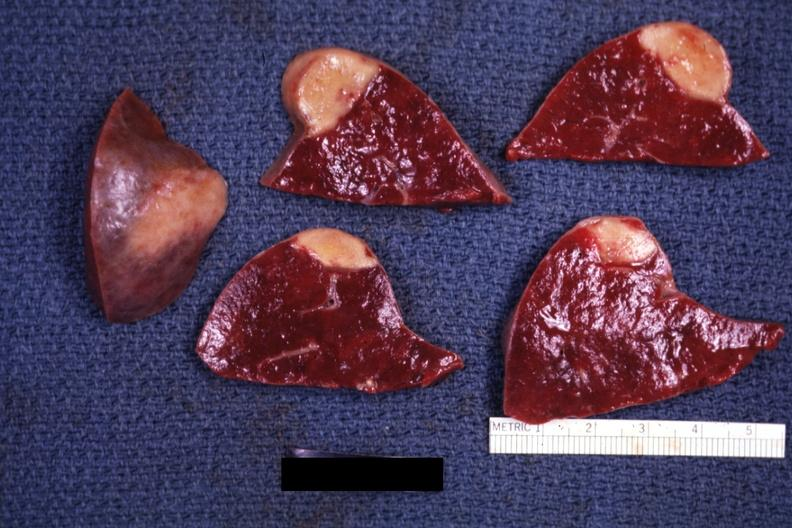how does this image show several slices?
Answer the question using a single word or phrase. With obvious lesion and one external view excellent example 